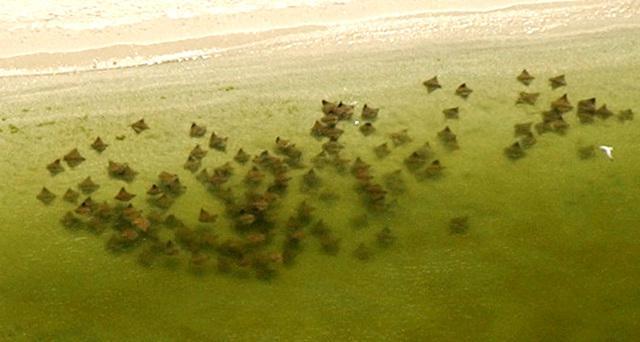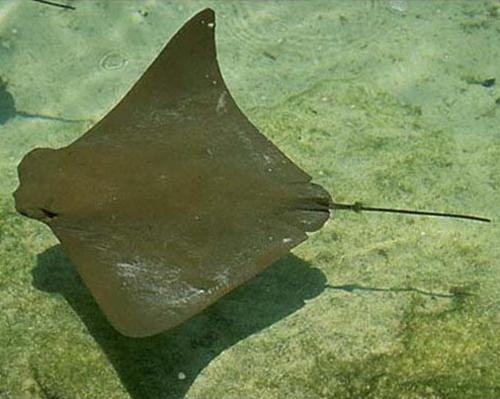The first image is the image on the left, the second image is the image on the right. For the images shown, is this caption "An image shows one stingray with spots on its skin." true? Answer yes or no. No. The first image is the image on the left, the second image is the image on the right. Considering the images on both sides, is "One of the images contains one sting ray with spots." valid? Answer yes or no. No. 